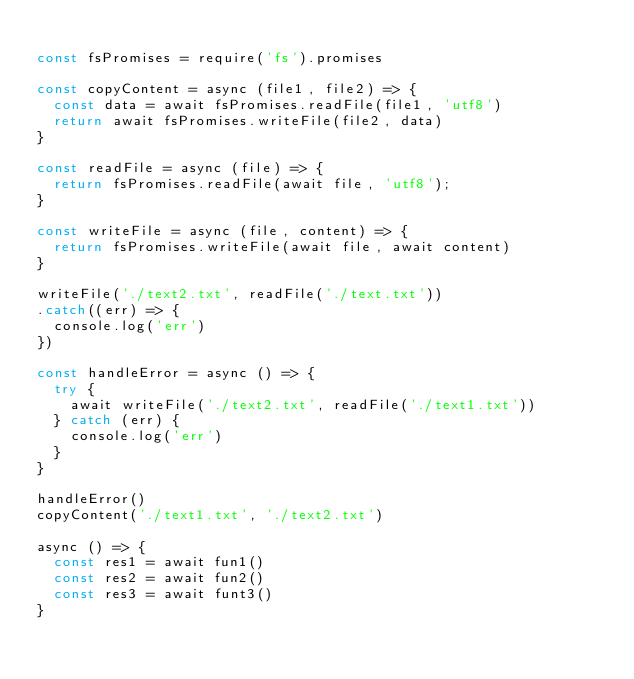<code> <loc_0><loc_0><loc_500><loc_500><_JavaScript_>
const fsPromises = require('fs').promises

const copyContent = async (file1, file2) => {
  const data = await fsPromises.readFile(file1, 'utf8')
  return await fsPromises.writeFile(file2, data)
}

const readFile = async (file) => {
  return fsPromises.readFile(await file, 'utf8');
}

const writeFile = async (file, content) => {
  return fsPromises.writeFile(await file, await content)
}

writeFile('./text2.txt', readFile('./text.txt'))
.catch((err) => {
  console.log('err')
})

const handleError = async () => {
  try {
    await writeFile('./text2.txt', readFile('./text1.txt'))
  } catch (err) {
    console.log('err')
  }
}

handleError()
copyContent('./text1.txt', './text2.txt')

async () => {
  const res1 = await fun1()
  const res2 = await fun2() 
  const res3 = await funt3()
}

</code> 